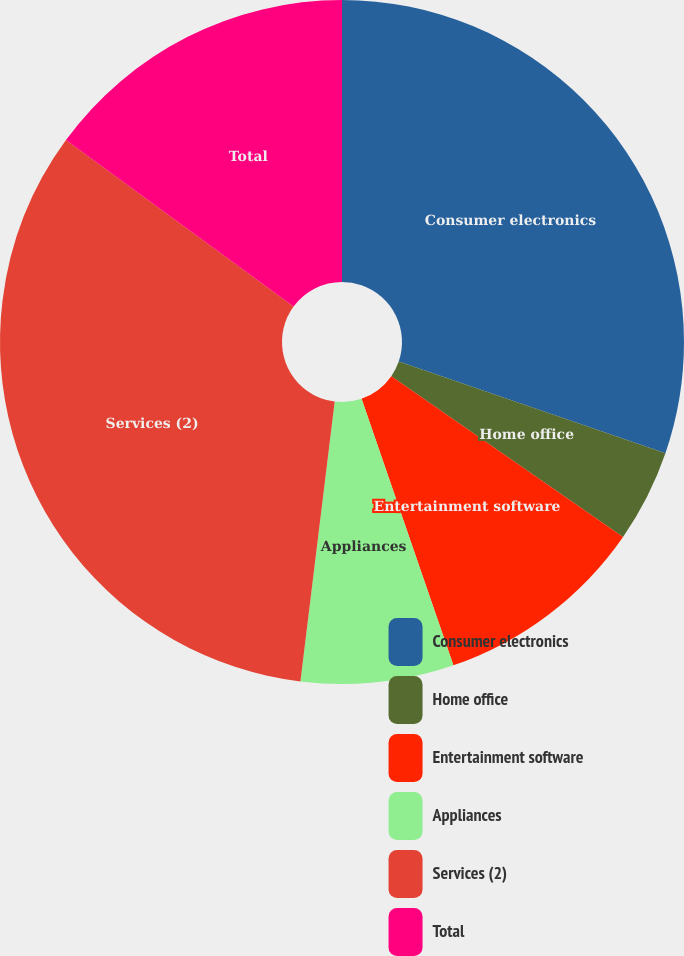<chart> <loc_0><loc_0><loc_500><loc_500><pie_chart><fcel>Consumer electronics<fcel>Home office<fcel>Entertainment software<fcel>Appliances<fcel>Services (2)<fcel>Total<nl><fcel>30.27%<fcel>4.38%<fcel>10.07%<fcel>7.22%<fcel>33.11%<fcel>14.95%<nl></chart> 